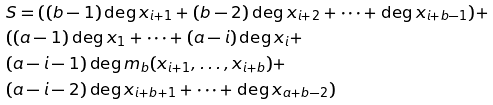Convert formula to latex. <formula><loc_0><loc_0><loc_500><loc_500>\ & S = ( ( b - 1 ) \deg x _ { i + 1 } + ( b - 2 ) \deg x _ { i + 2 } + \dots + \deg x _ { i + b - 1 } ) + \\ & ( ( a - 1 ) \deg x _ { 1 } + \dots + ( a - i ) \deg x _ { i } + \\ & ( a - i - 1 ) \deg m _ { b } ( x _ { i + 1 } , \dots , x _ { i + b } ) + \\ & ( a - i - 2 ) \deg x _ { i + b + 1 } + \dots + \deg x _ { a + b - 2 } )</formula> 